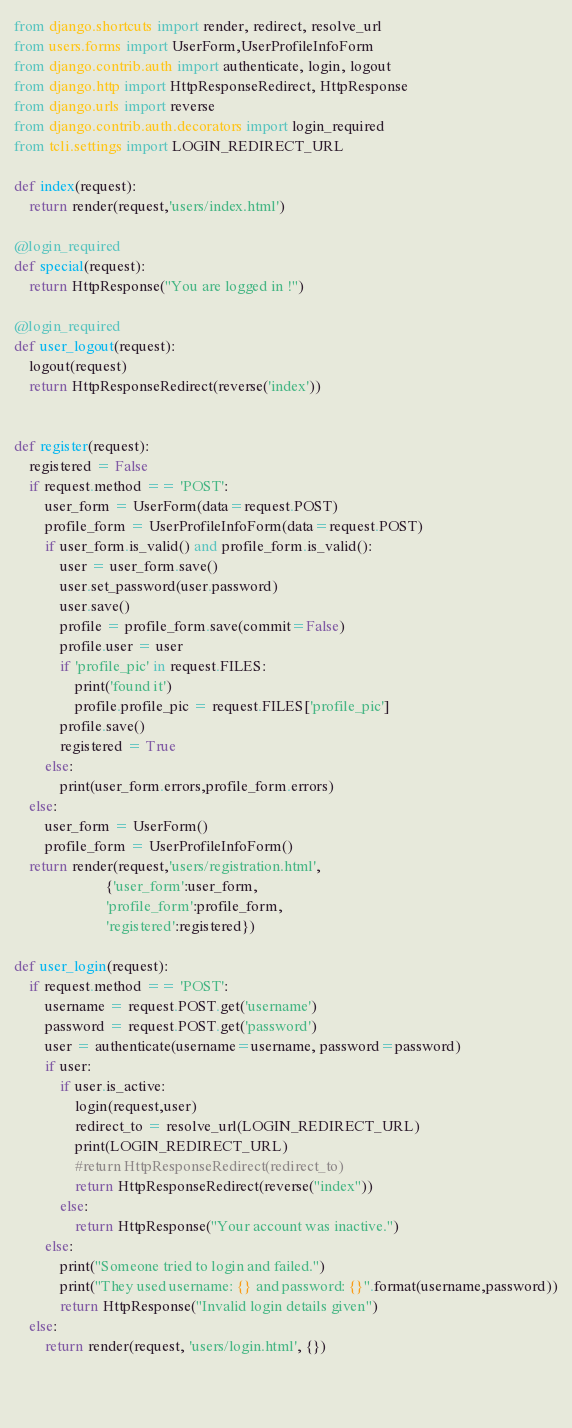<code> <loc_0><loc_0><loc_500><loc_500><_Python_>from django.shortcuts import render, redirect, resolve_urlfrom users.forms import UserForm,UserProfileInfoFormfrom django.contrib.auth import authenticate, login, logoutfrom django.http import HttpResponseRedirect, HttpResponsefrom django.urls import reversefrom django.contrib.auth.decorators import login_requiredfrom tcli.settings import LOGIN_REDIRECT_URLdef index(request):	return render(request,'users/index.html')@login_requireddef special(request):	return HttpResponse("You are logged in !")@login_requireddef user_logout(request):	logout(request)	return HttpResponseRedirect(reverse('index'))		def register(request):	registered = False	if request.method == 'POST':		user_form = UserForm(data=request.POST)		profile_form = UserProfileInfoForm(data=request.POST)		if user_form.is_valid() and profile_form.is_valid():			user = user_form.save()			user.set_password(user.password)			user.save()			profile = profile_form.save(commit=False)			profile.user = user			if 'profile_pic' in request.FILES:				print('found it')				profile.profile_pic = request.FILES['profile_pic']			profile.save()			registered = True		else:			print(user_form.errors,profile_form.errors)	else:		user_form = UserForm()		profile_form = UserProfileInfoForm()	return render(request,'users/registration.html',						{'user_form':user_form,						'profile_form':profile_form,						'registered':registered})						def user_login(request):    if request.method == 'POST':        username = request.POST.get('username')        password = request.POST.get('password')        user = authenticate(username=username, password=password)        if user:            if user.is_active:                login(request,user)                redirect_to = resolve_url(LOGIN_REDIRECT_URL)                print(LOGIN_REDIRECT_URL)                #return HttpResponseRedirect(redirect_to)                return HttpResponseRedirect(reverse("index"))            else:                return HttpResponse("Your account was inactive.")        else:            print("Someone tried to login and failed.")            print("They used username: {} and password: {}".format(username,password))            return HttpResponse("Invalid login details given")    else:        return render(request, 'users/login.html', {})					</code> 